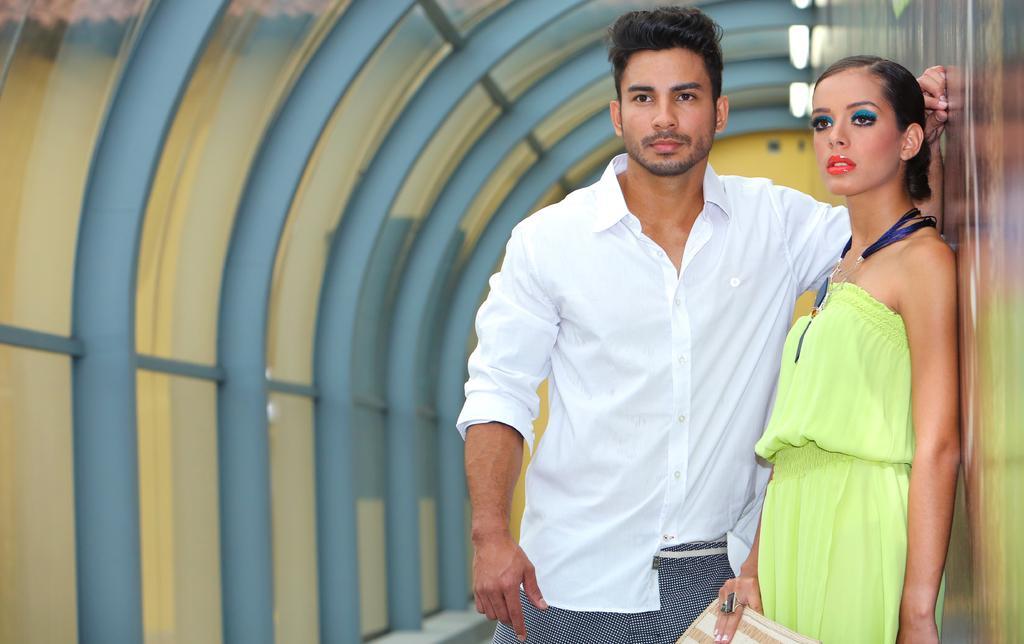Could you give a brief overview of what you see in this image? This picture looks like an inner view of a building, three lights, it looks like rods on the left side of the image, one man standing and touching the wall on the right side of the image. There are some objects in the background and the background is blurred. One woman standing near the wall and holding an object on the right side of the image. 